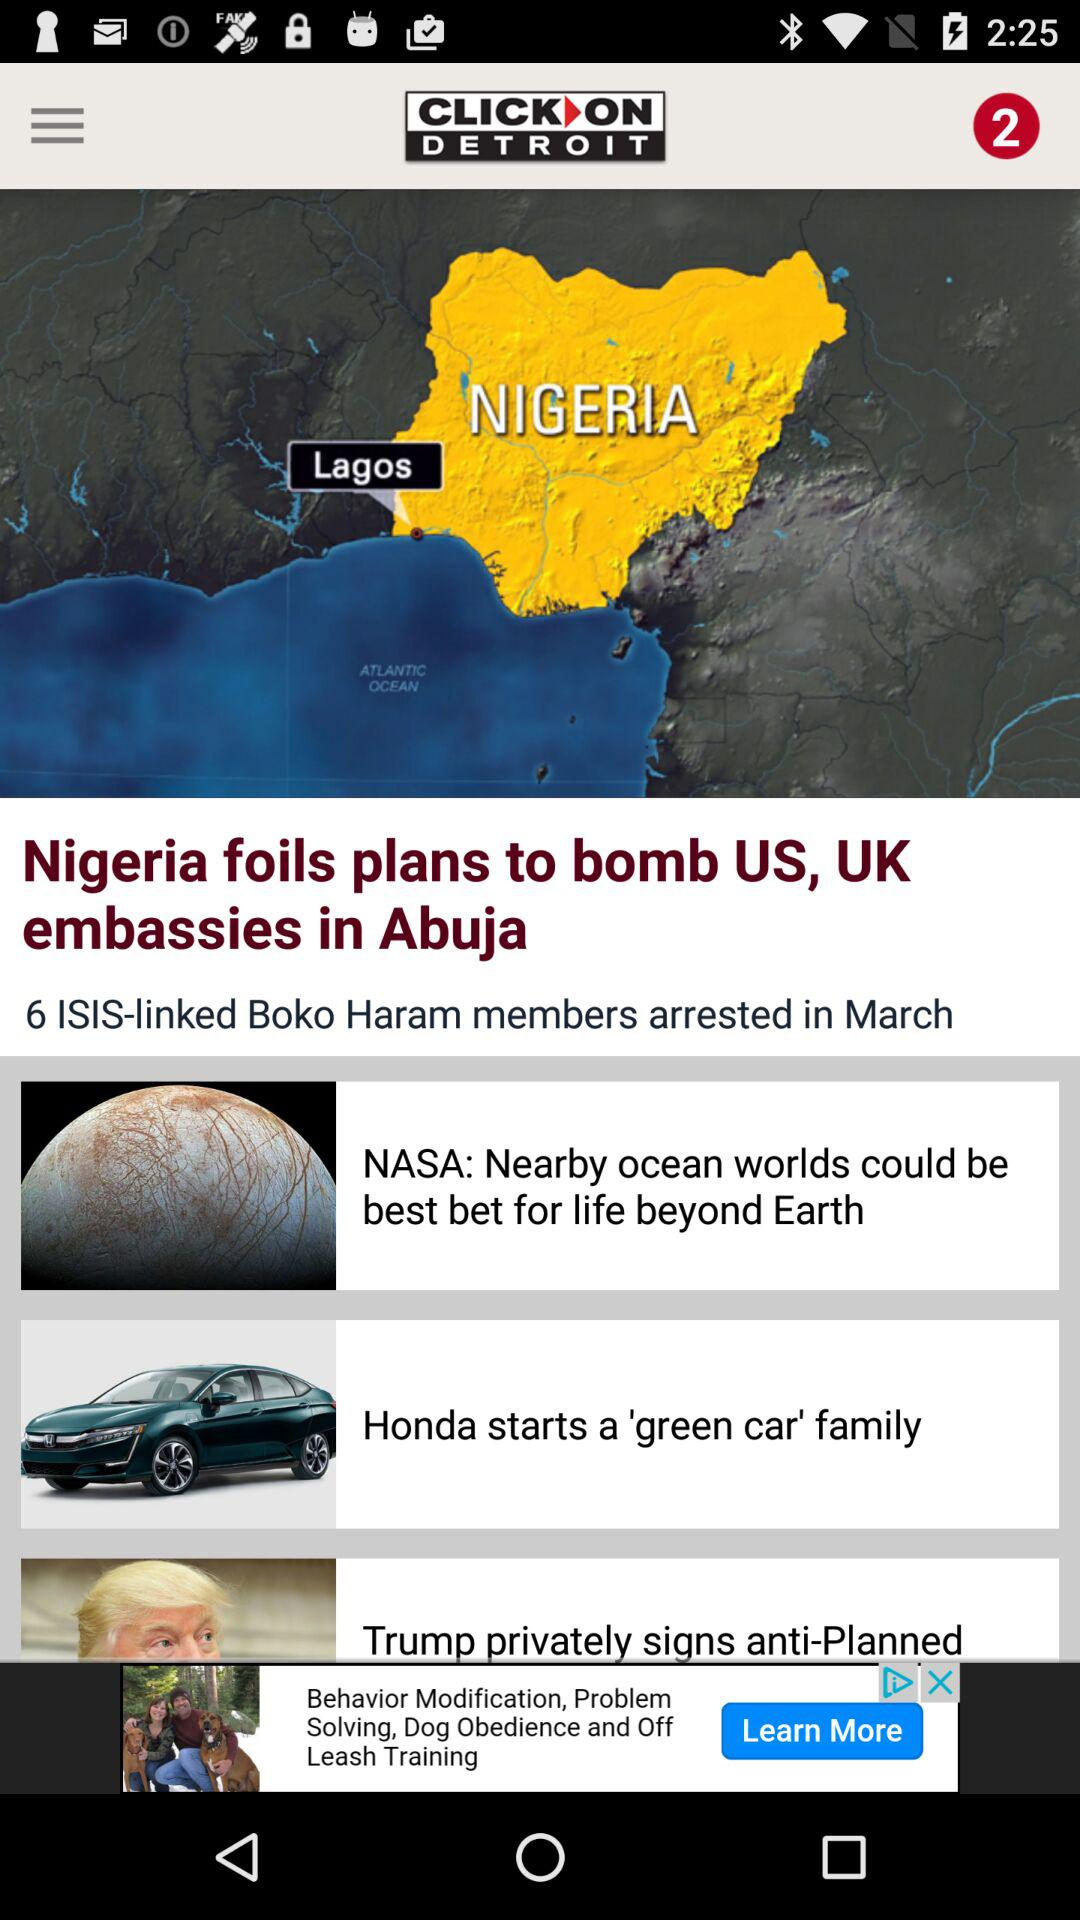When were the members of "Boko Haram" arrested? The members of "Boko Haram" were arrested in March. 